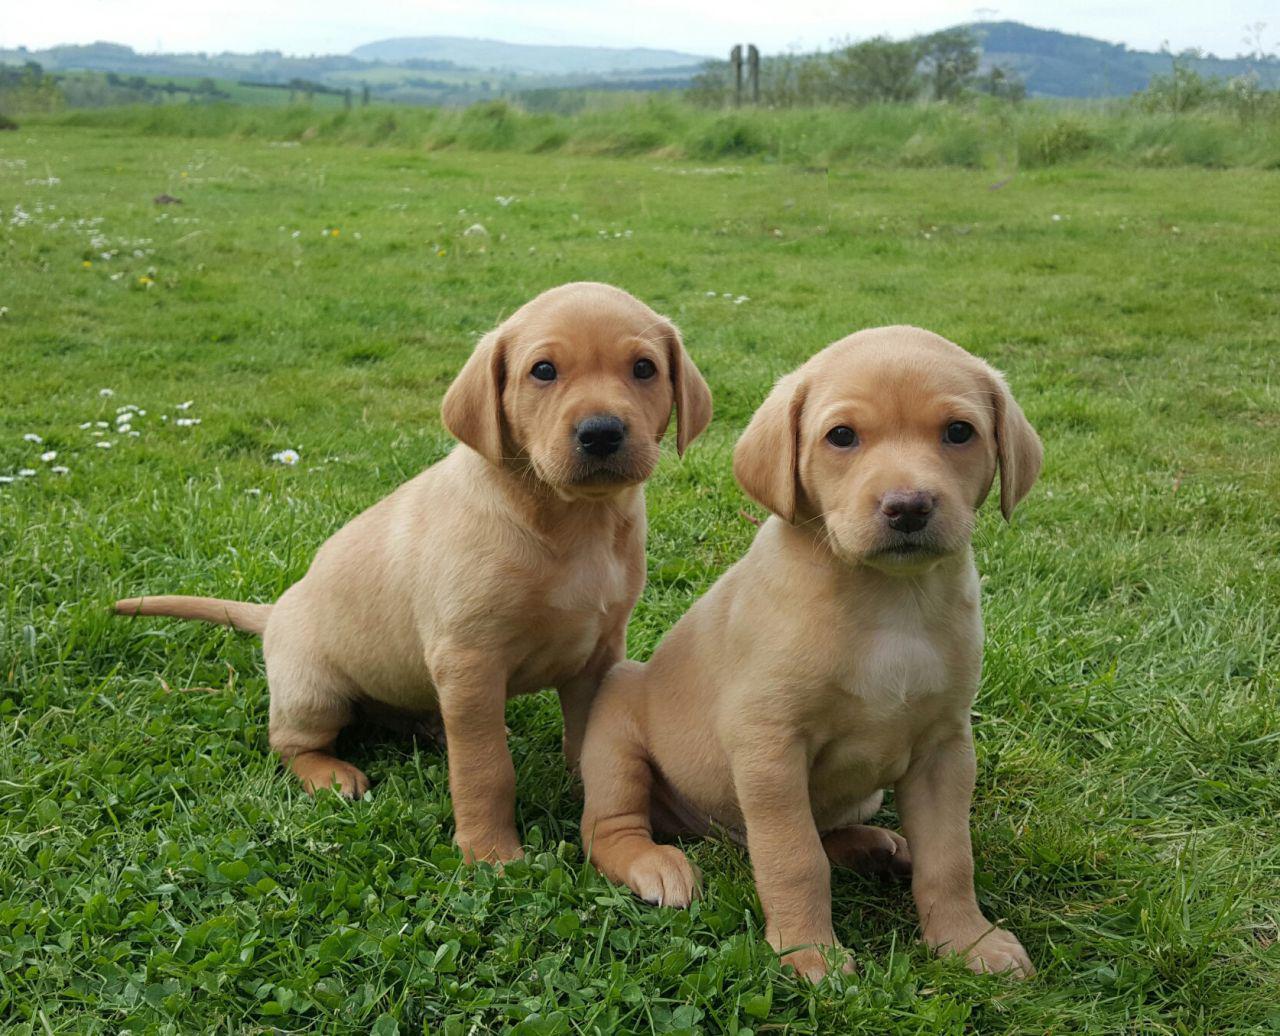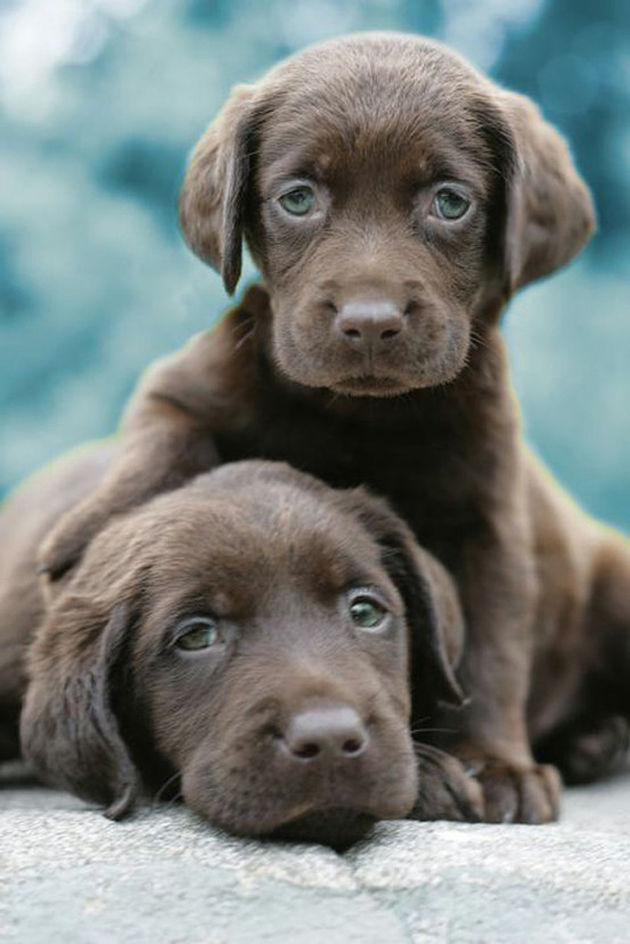The first image is the image on the left, the second image is the image on the right. Considering the images on both sides, is "A puppy has a paw around a dark brownish-gray puppy that is reclining." valid? Answer yes or no. Yes. The first image is the image on the left, the second image is the image on the right. Considering the images on both sides, is "Two dogs are lying down in the image on the left." valid? Answer yes or no. No. 